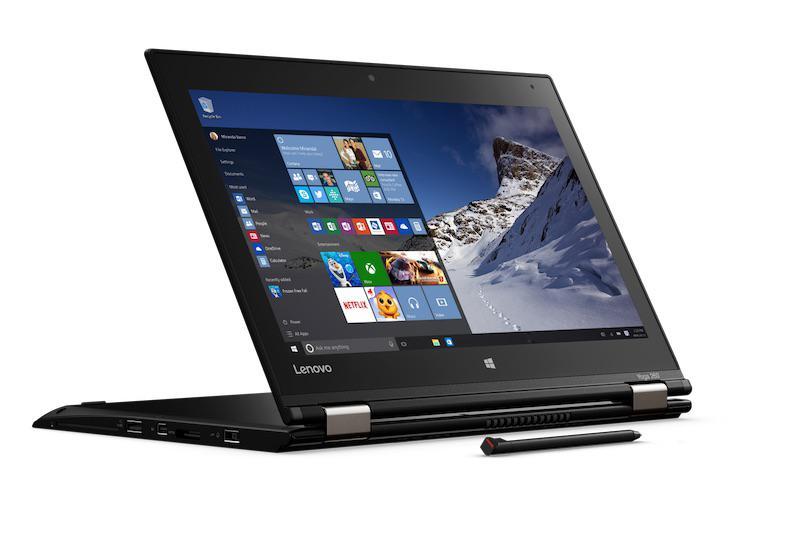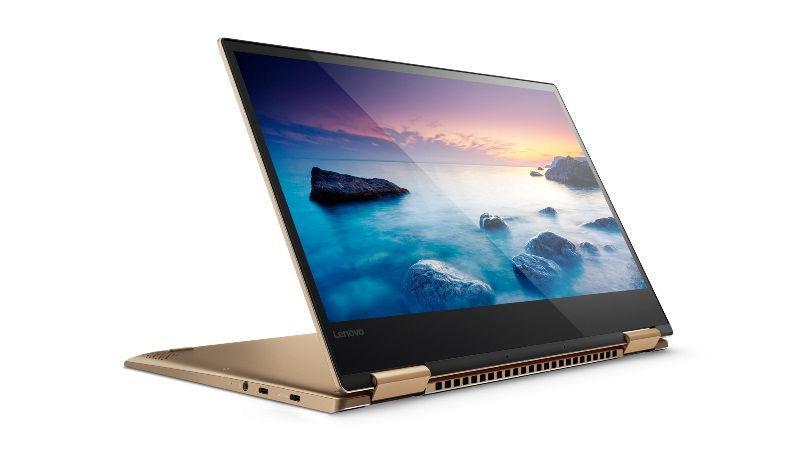The first image is the image on the left, the second image is the image on the right. Given the left and right images, does the statement "Each image shows an open tablet laptop sitting flat on its keyboard base, with a picture on its screen, and at least one image shows the screen reversed so the picture is on the back." hold true? Answer yes or no. Yes. 